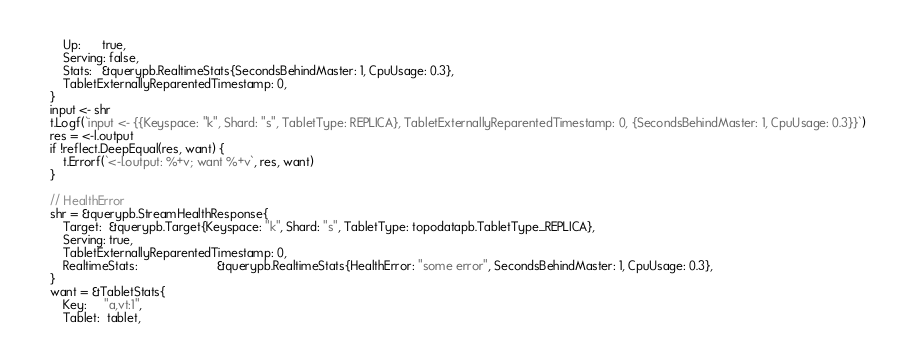Convert code to text. <code><loc_0><loc_0><loc_500><loc_500><_Go_>		Up:      true,
		Serving: false,
		Stats:   &querypb.RealtimeStats{SecondsBehindMaster: 1, CpuUsage: 0.3},
		TabletExternallyReparentedTimestamp: 0,
	}
	input <- shr
	t.Logf(`input <- {{Keyspace: "k", Shard: "s", TabletType: REPLICA}, TabletExternallyReparentedTimestamp: 0, {SecondsBehindMaster: 1, CpuUsage: 0.3}}`)
	res = <-l.output
	if !reflect.DeepEqual(res, want) {
		t.Errorf(`<-l.output: %+v; want %+v`, res, want)
	}

	// HealthError
	shr = &querypb.StreamHealthResponse{
		Target:  &querypb.Target{Keyspace: "k", Shard: "s", TabletType: topodatapb.TabletType_REPLICA},
		Serving: true,
		TabletExternallyReparentedTimestamp: 0,
		RealtimeStats:                       &querypb.RealtimeStats{HealthError: "some error", SecondsBehindMaster: 1, CpuUsage: 0.3},
	}
	want = &TabletStats{
		Key:     "a,vt:1",
		Tablet:  tablet,</code> 